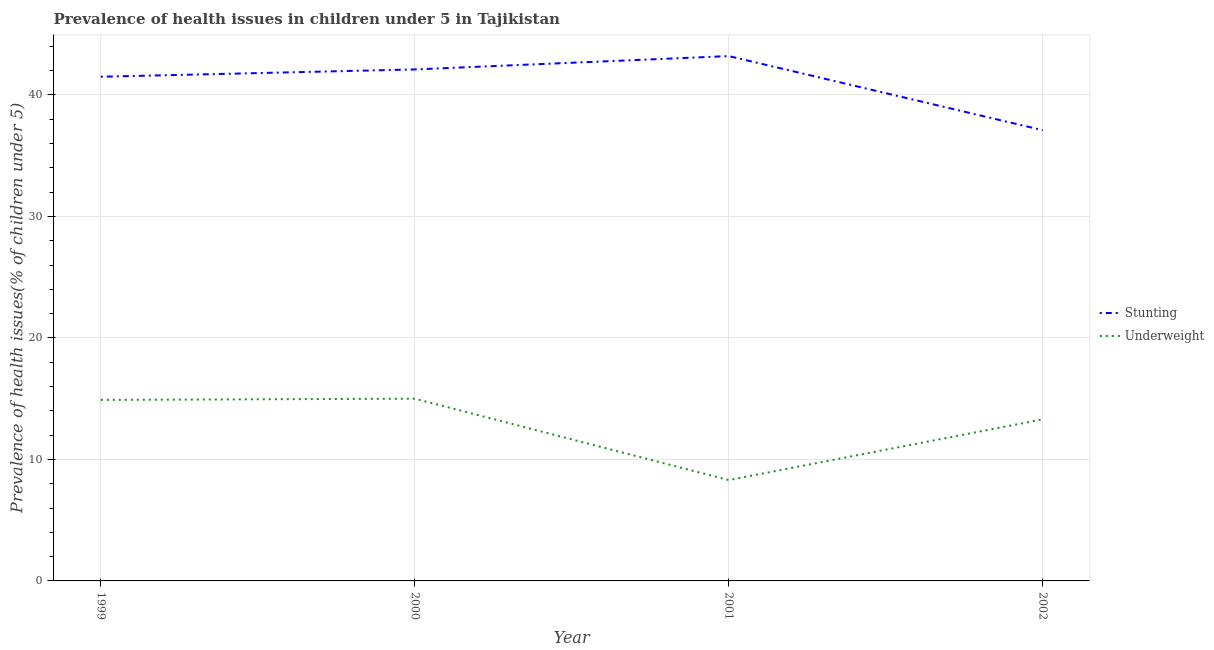What is the percentage of underweight children in 2001?
Give a very brief answer. 8.3. Across all years, what is the maximum percentage of underweight children?
Offer a very short reply. 15. Across all years, what is the minimum percentage of stunted children?
Offer a very short reply. 37.1. In which year was the percentage of underweight children minimum?
Keep it short and to the point. 2001. What is the total percentage of stunted children in the graph?
Make the answer very short. 163.9. What is the difference between the percentage of underweight children in 2000 and that in 2002?
Make the answer very short. 1.7. What is the difference between the percentage of stunted children in 2002 and the percentage of underweight children in 2001?
Offer a terse response. 28.8. What is the average percentage of stunted children per year?
Your answer should be very brief. 40.97. In the year 2001, what is the difference between the percentage of underweight children and percentage of stunted children?
Give a very brief answer. -34.9. What is the ratio of the percentage of underweight children in 1999 to that in 2002?
Give a very brief answer. 1.12. Is the difference between the percentage of underweight children in 2000 and 2002 greater than the difference between the percentage of stunted children in 2000 and 2002?
Your answer should be very brief. No. What is the difference between the highest and the second highest percentage of underweight children?
Provide a succinct answer. 0.1. What is the difference between the highest and the lowest percentage of stunted children?
Your answer should be very brief. 6.1. In how many years, is the percentage of stunted children greater than the average percentage of stunted children taken over all years?
Provide a short and direct response. 3. Does the percentage of underweight children monotonically increase over the years?
Give a very brief answer. No. Is the percentage of stunted children strictly less than the percentage of underweight children over the years?
Give a very brief answer. No. How many lines are there?
Keep it short and to the point. 2. What is the difference between two consecutive major ticks on the Y-axis?
Ensure brevity in your answer.  10. Does the graph contain any zero values?
Your response must be concise. No. Does the graph contain grids?
Provide a short and direct response. Yes. Where does the legend appear in the graph?
Provide a succinct answer. Center right. What is the title of the graph?
Offer a very short reply. Prevalence of health issues in children under 5 in Tajikistan. Does "Under-5(female)" appear as one of the legend labels in the graph?
Offer a very short reply. No. What is the label or title of the X-axis?
Give a very brief answer. Year. What is the label or title of the Y-axis?
Make the answer very short. Prevalence of health issues(% of children under 5). What is the Prevalence of health issues(% of children under 5) of Stunting in 1999?
Offer a terse response. 41.5. What is the Prevalence of health issues(% of children under 5) of Underweight in 1999?
Your answer should be compact. 14.9. What is the Prevalence of health issues(% of children under 5) in Stunting in 2000?
Your response must be concise. 42.1. What is the Prevalence of health issues(% of children under 5) in Underweight in 2000?
Provide a short and direct response. 15. What is the Prevalence of health issues(% of children under 5) of Stunting in 2001?
Your response must be concise. 43.2. What is the Prevalence of health issues(% of children under 5) of Underweight in 2001?
Make the answer very short. 8.3. What is the Prevalence of health issues(% of children under 5) of Stunting in 2002?
Give a very brief answer. 37.1. What is the Prevalence of health issues(% of children under 5) of Underweight in 2002?
Offer a terse response. 13.3. Across all years, what is the maximum Prevalence of health issues(% of children under 5) of Stunting?
Make the answer very short. 43.2. Across all years, what is the maximum Prevalence of health issues(% of children under 5) in Underweight?
Your response must be concise. 15. Across all years, what is the minimum Prevalence of health issues(% of children under 5) of Stunting?
Provide a succinct answer. 37.1. Across all years, what is the minimum Prevalence of health issues(% of children under 5) in Underweight?
Keep it short and to the point. 8.3. What is the total Prevalence of health issues(% of children under 5) in Stunting in the graph?
Your answer should be very brief. 163.9. What is the total Prevalence of health issues(% of children under 5) of Underweight in the graph?
Provide a succinct answer. 51.5. What is the difference between the Prevalence of health issues(% of children under 5) of Underweight in 1999 and that in 2000?
Offer a terse response. -0.1. What is the difference between the Prevalence of health issues(% of children under 5) in Stunting in 1999 and that in 2001?
Give a very brief answer. -1.7. What is the difference between the Prevalence of health issues(% of children under 5) of Stunting in 1999 and that in 2002?
Offer a terse response. 4.4. What is the difference between the Prevalence of health issues(% of children under 5) in Underweight in 1999 and that in 2002?
Your answer should be compact. 1.6. What is the difference between the Prevalence of health issues(% of children under 5) of Stunting in 2000 and that in 2002?
Ensure brevity in your answer.  5. What is the difference between the Prevalence of health issues(% of children under 5) in Stunting in 1999 and the Prevalence of health issues(% of children under 5) in Underweight in 2000?
Keep it short and to the point. 26.5. What is the difference between the Prevalence of health issues(% of children under 5) of Stunting in 1999 and the Prevalence of health issues(% of children under 5) of Underweight in 2001?
Offer a terse response. 33.2. What is the difference between the Prevalence of health issues(% of children under 5) in Stunting in 1999 and the Prevalence of health issues(% of children under 5) in Underweight in 2002?
Ensure brevity in your answer.  28.2. What is the difference between the Prevalence of health issues(% of children under 5) in Stunting in 2000 and the Prevalence of health issues(% of children under 5) in Underweight in 2001?
Offer a terse response. 33.8. What is the difference between the Prevalence of health issues(% of children under 5) in Stunting in 2000 and the Prevalence of health issues(% of children under 5) in Underweight in 2002?
Provide a short and direct response. 28.8. What is the difference between the Prevalence of health issues(% of children under 5) of Stunting in 2001 and the Prevalence of health issues(% of children under 5) of Underweight in 2002?
Give a very brief answer. 29.9. What is the average Prevalence of health issues(% of children under 5) of Stunting per year?
Make the answer very short. 40.98. What is the average Prevalence of health issues(% of children under 5) of Underweight per year?
Provide a short and direct response. 12.88. In the year 1999, what is the difference between the Prevalence of health issues(% of children under 5) of Stunting and Prevalence of health issues(% of children under 5) of Underweight?
Ensure brevity in your answer.  26.6. In the year 2000, what is the difference between the Prevalence of health issues(% of children under 5) of Stunting and Prevalence of health issues(% of children under 5) of Underweight?
Your response must be concise. 27.1. In the year 2001, what is the difference between the Prevalence of health issues(% of children under 5) in Stunting and Prevalence of health issues(% of children under 5) in Underweight?
Keep it short and to the point. 34.9. In the year 2002, what is the difference between the Prevalence of health issues(% of children under 5) of Stunting and Prevalence of health issues(% of children under 5) of Underweight?
Make the answer very short. 23.8. What is the ratio of the Prevalence of health issues(% of children under 5) of Stunting in 1999 to that in 2000?
Keep it short and to the point. 0.99. What is the ratio of the Prevalence of health issues(% of children under 5) in Underweight in 1999 to that in 2000?
Provide a short and direct response. 0.99. What is the ratio of the Prevalence of health issues(% of children under 5) of Stunting in 1999 to that in 2001?
Make the answer very short. 0.96. What is the ratio of the Prevalence of health issues(% of children under 5) in Underweight in 1999 to that in 2001?
Your answer should be very brief. 1.8. What is the ratio of the Prevalence of health issues(% of children under 5) in Stunting in 1999 to that in 2002?
Make the answer very short. 1.12. What is the ratio of the Prevalence of health issues(% of children under 5) in Underweight in 1999 to that in 2002?
Your response must be concise. 1.12. What is the ratio of the Prevalence of health issues(% of children under 5) in Stunting in 2000 to that in 2001?
Your response must be concise. 0.97. What is the ratio of the Prevalence of health issues(% of children under 5) in Underweight in 2000 to that in 2001?
Keep it short and to the point. 1.81. What is the ratio of the Prevalence of health issues(% of children under 5) of Stunting in 2000 to that in 2002?
Keep it short and to the point. 1.13. What is the ratio of the Prevalence of health issues(% of children under 5) in Underweight in 2000 to that in 2002?
Keep it short and to the point. 1.13. What is the ratio of the Prevalence of health issues(% of children under 5) of Stunting in 2001 to that in 2002?
Make the answer very short. 1.16. What is the ratio of the Prevalence of health issues(% of children under 5) in Underweight in 2001 to that in 2002?
Ensure brevity in your answer.  0.62. 